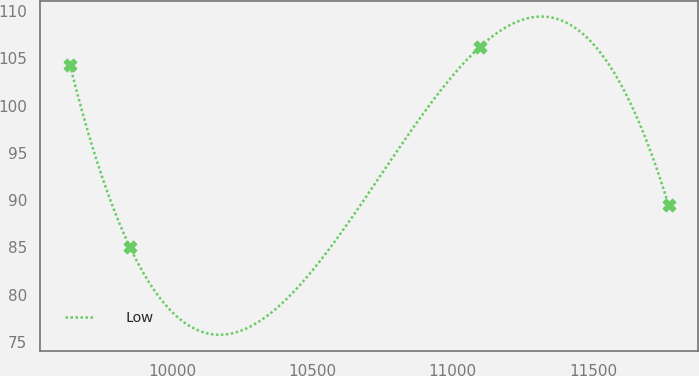Convert chart. <chart><loc_0><loc_0><loc_500><loc_500><line_chart><ecel><fcel>Low<nl><fcel>9634.93<fcel>104.27<nl><fcel>9848.4<fcel>85.04<nl><fcel>11097.8<fcel>106.23<nl><fcel>11769.6<fcel>89.49<nl></chart> 